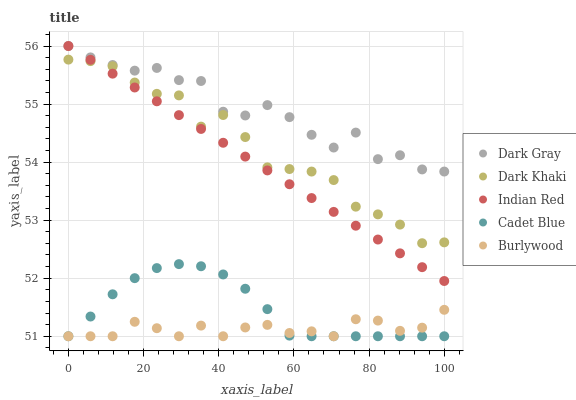Does Burlywood have the minimum area under the curve?
Answer yes or no. Yes. Does Dark Gray have the maximum area under the curve?
Answer yes or no. Yes. Does Dark Khaki have the minimum area under the curve?
Answer yes or no. No. Does Dark Khaki have the maximum area under the curve?
Answer yes or no. No. Is Indian Red the smoothest?
Answer yes or no. Yes. Is Dark Gray the roughest?
Answer yes or no. Yes. Is Dark Khaki the smoothest?
Answer yes or no. No. Is Dark Khaki the roughest?
Answer yes or no. No. Does Cadet Blue have the lowest value?
Answer yes or no. Yes. Does Dark Khaki have the lowest value?
Answer yes or no. No. Does Indian Red have the highest value?
Answer yes or no. Yes. Does Dark Khaki have the highest value?
Answer yes or no. No. Is Dark Khaki less than Dark Gray?
Answer yes or no. Yes. Is Dark Gray greater than Burlywood?
Answer yes or no. Yes. Does Dark Gray intersect Indian Red?
Answer yes or no. Yes. Is Dark Gray less than Indian Red?
Answer yes or no. No. Is Dark Gray greater than Indian Red?
Answer yes or no. No. Does Dark Khaki intersect Dark Gray?
Answer yes or no. No. 